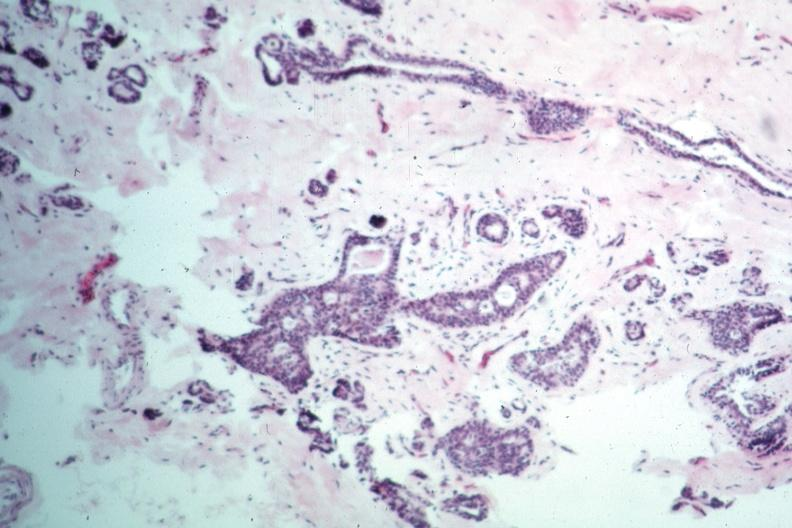does siamese twins appear benign?
Answer the question using a single word or phrase. No 